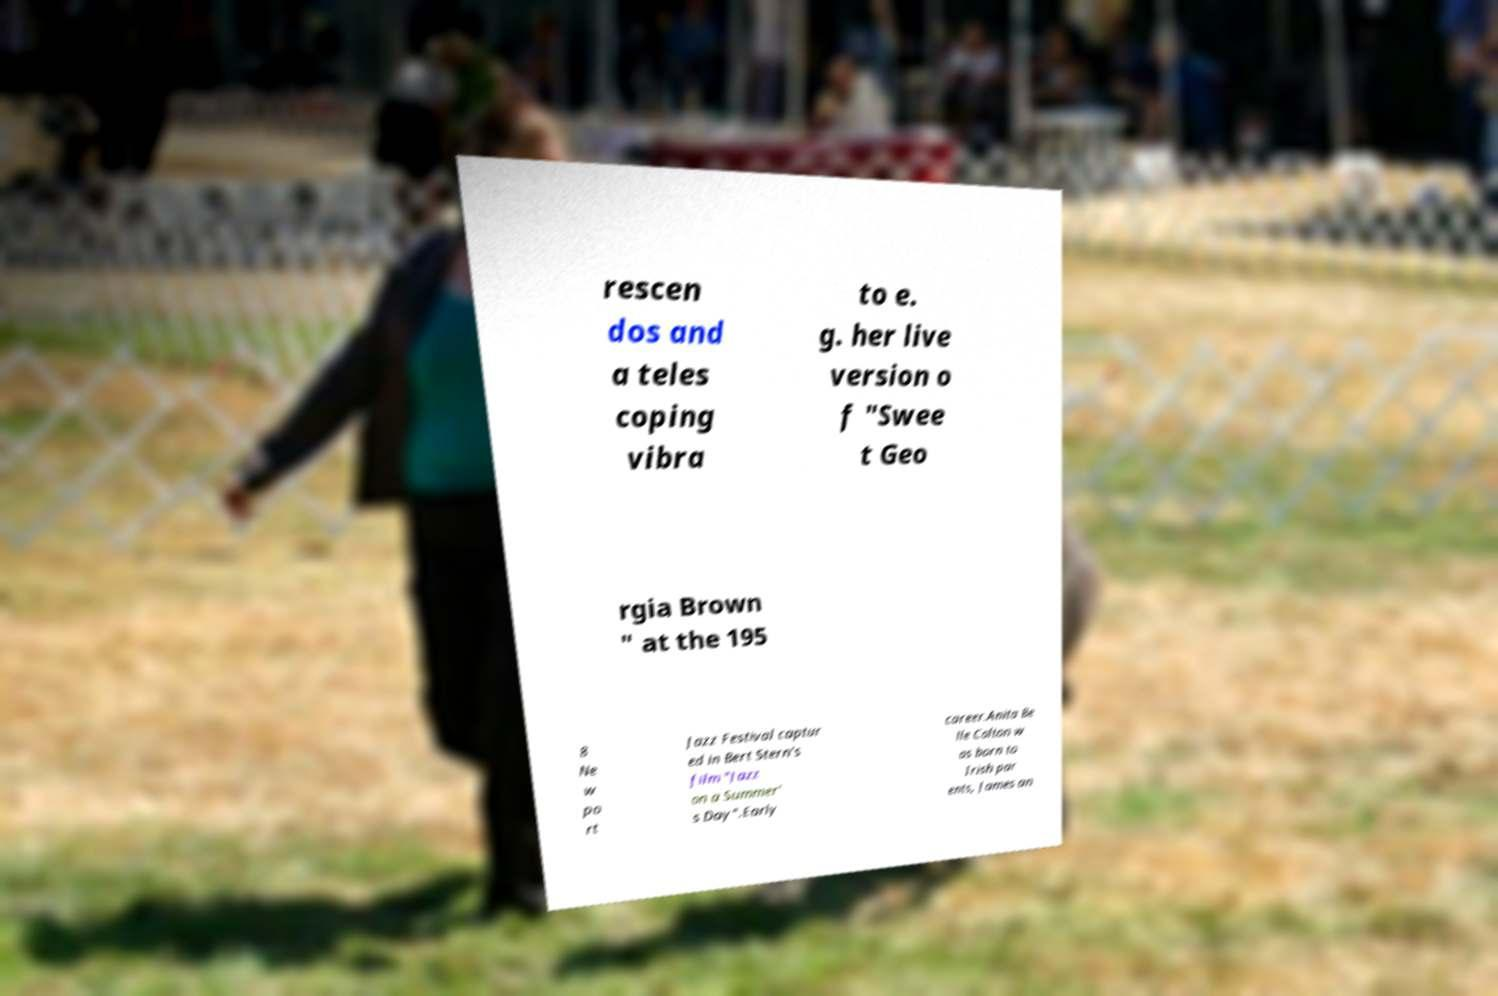Can you accurately transcribe the text from the provided image for me? rescen dos and a teles coping vibra to e. g. her live version o f "Swee t Geo rgia Brown " at the 195 8 Ne w po rt Jazz Festival captur ed in Bert Stern's film "Jazz on a Summer' s Day".Early career.Anita Be lle Colton w as born to Irish par ents, James an 